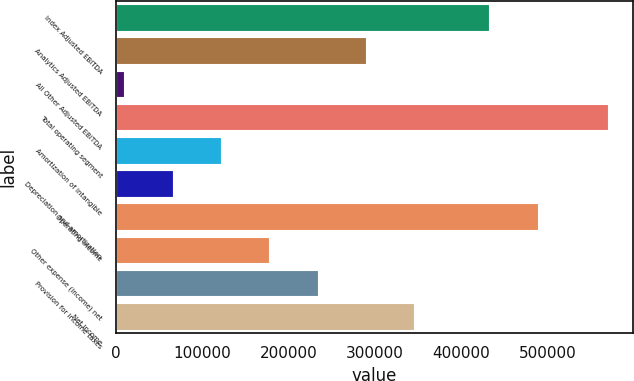Convert chart to OTSL. <chart><loc_0><loc_0><loc_500><loc_500><bar_chart><fcel>Index Adjusted EBITDA<fcel>Analytics Adjusted EBITDA<fcel>All Other Adjusted EBITDA<fcel>Total operating segment<fcel>Amortization of intangible<fcel>Depreciation and amortization<fcel>Operating income<fcel>Other expense (income) net<fcel>Provision for income taxes<fcel>Net income<nl><fcel>431478<fcel>289464<fcel>9472<fcel>569457<fcel>121469<fcel>65470.5<fcel>488104<fcel>177468<fcel>233466<fcel>345463<nl></chart> 